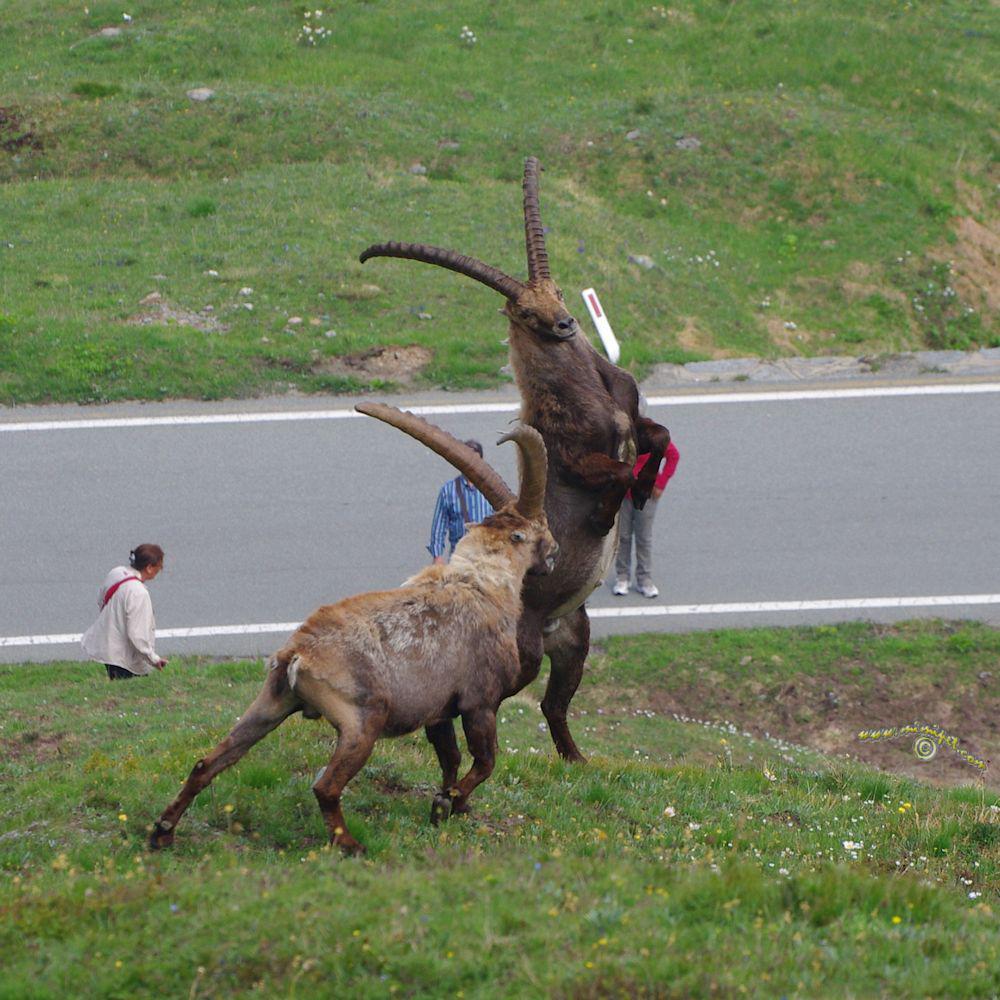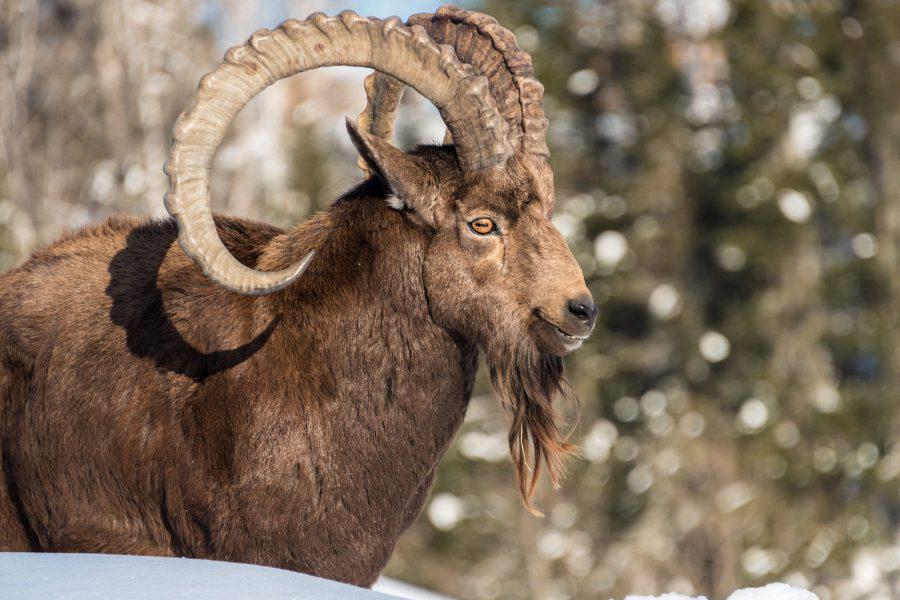The first image is the image on the left, the second image is the image on the right. Analyze the images presented: Is the assertion "There is a total of three antelopes." valid? Answer yes or no. Yes. The first image is the image on the left, the second image is the image on the right. For the images shown, is this caption "The left and right image contains a total of three goat.." true? Answer yes or no. Yes. 